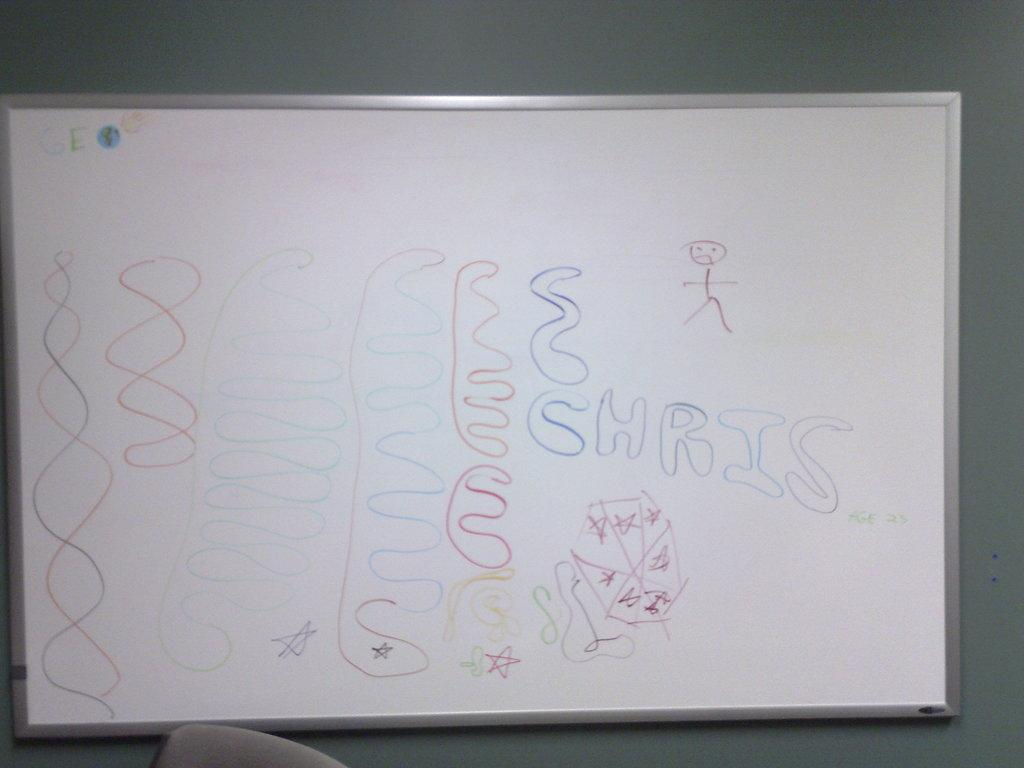<image>
Render a clear and concise summary of the photo. a write on wipe off whiteboard has drawings and the name Chris on it 